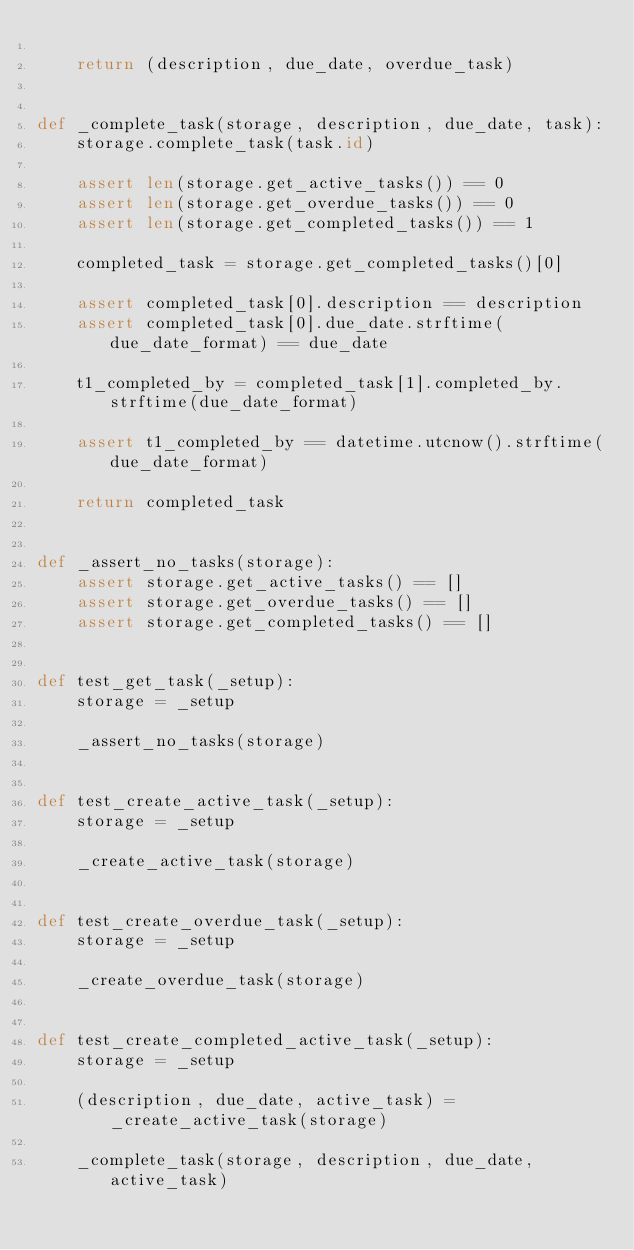<code> <loc_0><loc_0><loc_500><loc_500><_Python_>
    return (description, due_date, overdue_task)


def _complete_task(storage, description, due_date, task):
    storage.complete_task(task.id)

    assert len(storage.get_active_tasks()) == 0
    assert len(storage.get_overdue_tasks()) == 0
    assert len(storage.get_completed_tasks()) == 1

    completed_task = storage.get_completed_tasks()[0]

    assert completed_task[0].description == description
    assert completed_task[0].due_date.strftime(due_date_format) == due_date

    t1_completed_by = completed_task[1].completed_by.strftime(due_date_format)

    assert t1_completed_by == datetime.utcnow().strftime(due_date_format)

    return completed_task


def _assert_no_tasks(storage):
    assert storage.get_active_tasks() == []
    assert storage.get_overdue_tasks() == []
    assert storage.get_completed_tasks() == []


def test_get_task(_setup):
    storage = _setup

    _assert_no_tasks(storage)


def test_create_active_task(_setup):
    storage = _setup

    _create_active_task(storage)


def test_create_overdue_task(_setup):
    storage = _setup

    _create_overdue_task(storage)


def test_create_completed_active_task(_setup):
    storage = _setup

    (description, due_date, active_task) = _create_active_task(storage)

    _complete_task(storage, description, due_date, active_task)

</code> 